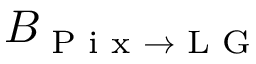Convert formula to latex. <formula><loc_0><loc_0><loc_500><loc_500>B _ { P i x \rightarrow L G }</formula> 